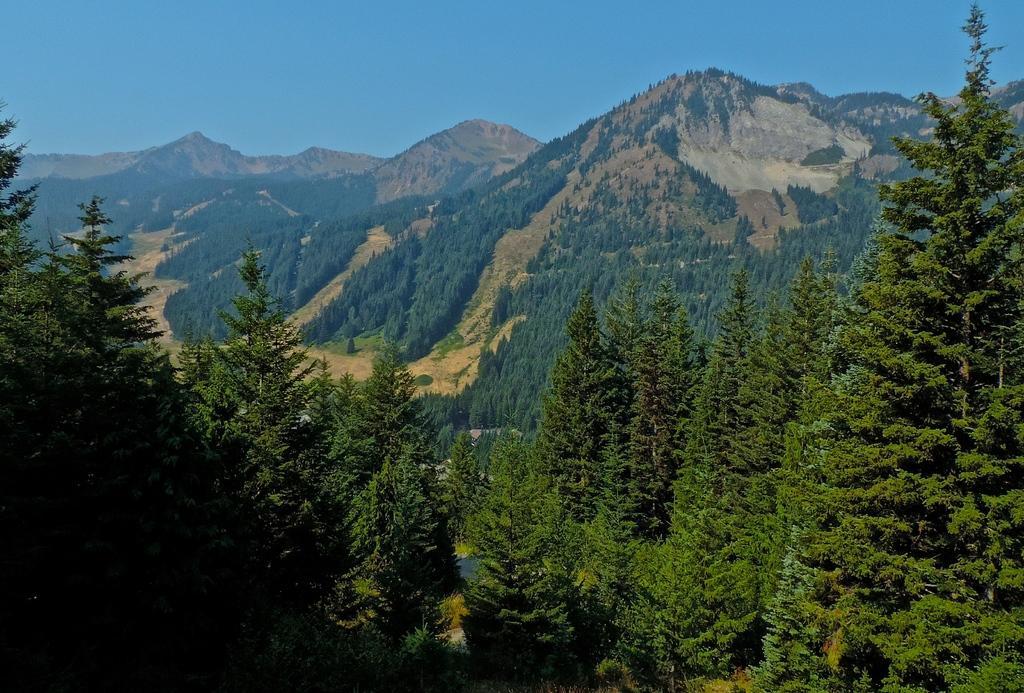In one or two sentences, can you explain what this image depicts? Bottom of the image there are some trees. Behind the trees there are some hills. Top of the image there is sky. 